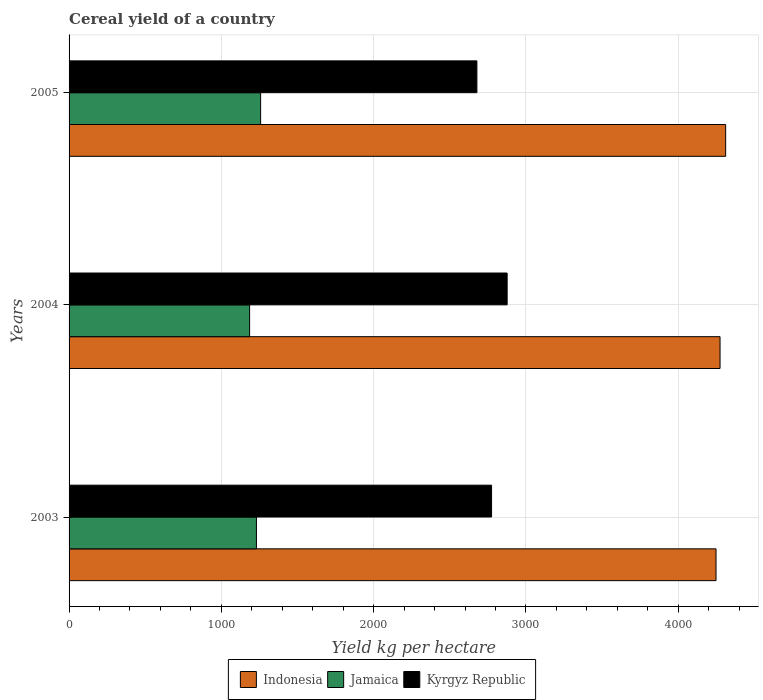How many different coloured bars are there?
Provide a succinct answer. 3. Are the number of bars per tick equal to the number of legend labels?
Provide a succinct answer. Yes. Are the number of bars on each tick of the Y-axis equal?
Give a very brief answer. Yes. How many bars are there on the 2nd tick from the top?
Your answer should be compact. 3. What is the total cereal yield in Kyrgyz Republic in 2004?
Provide a succinct answer. 2876.46. Across all years, what is the maximum total cereal yield in Jamaica?
Ensure brevity in your answer.  1257.81. Across all years, what is the minimum total cereal yield in Kyrgyz Republic?
Your answer should be very brief. 2677.87. In which year was the total cereal yield in Indonesia maximum?
Your response must be concise. 2005. In which year was the total cereal yield in Indonesia minimum?
Offer a very short reply. 2003. What is the total total cereal yield in Indonesia in the graph?
Offer a terse response. 1.28e+04. What is the difference between the total cereal yield in Kyrgyz Republic in 2004 and that in 2005?
Your response must be concise. 198.59. What is the difference between the total cereal yield in Indonesia in 2005 and the total cereal yield in Kyrgyz Republic in 2003?
Provide a short and direct response. 1537.18. What is the average total cereal yield in Indonesia per year?
Give a very brief answer. 4277.97. In the year 2003, what is the difference between the total cereal yield in Jamaica and total cereal yield in Indonesia?
Give a very brief answer. -3017.82. In how many years, is the total cereal yield in Kyrgyz Republic greater than 3800 kg per hectare?
Keep it short and to the point. 0. What is the ratio of the total cereal yield in Kyrgyz Republic in 2003 to that in 2005?
Make the answer very short. 1.04. Is the total cereal yield in Indonesia in 2003 less than that in 2005?
Your answer should be very brief. Yes. What is the difference between the highest and the second highest total cereal yield in Kyrgyz Republic?
Ensure brevity in your answer.  102.31. What is the difference between the highest and the lowest total cereal yield in Jamaica?
Make the answer very short. 72.38. In how many years, is the total cereal yield in Jamaica greater than the average total cereal yield in Jamaica taken over all years?
Your response must be concise. 2. Is the sum of the total cereal yield in Kyrgyz Republic in 2004 and 2005 greater than the maximum total cereal yield in Jamaica across all years?
Your response must be concise. Yes. What does the 3rd bar from the top in 2004 represents?
Offer a very short reply. Indonesia. What does the 1st bar from the bottom in 2004 represents?
Offer a terse response. Indonesia. How many bars are there?
Give a very brief answer. 9. Does the graph contain any zero values?
Offer a very short reply. No. Where does the legend appear in the graph?
Your response must be concise. Bottom center. How many legend labels are there?
Keep it short and to the point. 3. What is the title of the graph?
Your answer should be compact. Cereal yield of a country. Does "Europe(developing only)" appear as one of the legend labels in the graph?
Your response must be concise. No. What is the label or title of the X-axis?
Provide a succinct answer. Yield kg per hectare. What is the Yield kg per hectare of Indonesia in 2003?
Your response must be concise. 4248.09. What is the Yield kg per hectare of Jamaica in 2003?
Provide a short and direct response. 1230.26. What is the Yield kg per hectare in Kyrgyz Republic in 2003?
Provide a short and direct response. 2774.15. What is the Yield kg per hectare in Indonesia in 2004?
Your answer should be very brief. 4274.49. What is the Yield kg per hectare of Jamaica in 2004?
Make the answer very short. 1185.43. What is the Yield kg per hectare in Kyrgyz Republic in 2004?
Your answer should be very brief. 2876.46. What is the Yield kg per hectare in Indonesia in 2005?
Offer a terse response. 4311.34. What is the Yield kg per hectare in Jamaica in 2005?
Make the answer very short. 1257.81. What is the Yield kg per hectare of Kyrgyz Republic in 2005?
Your answer should be compact. 2677.87. Across all years, what is the maximum Yield kg per hectare in Indonesia?
Make the answer very short. 4311.34. Across all years, what is the maximum Yield kg per hectare in Jamaica?
Your answer should be compact. 1257.81. Across all years, what is the maximum Yield kg per hectare in Kyrgyz Republic?
Provide a short and direct response. 2876.46. Across all years, what is the minimum Yield kg per hectare of Indonesia?
Offer a very short reply. 4248.09. Across all years, what is the minimum Yield kg per hectare in Jamaica?
Your answer should be compact. 1185.43. Across all years, what is the minimum Yield kg per hectare of Kyrgyz Republic?
Ensure brevity in your answer.  2677.87. What is the total Yield kg per hectare of Indonesia in the graph?
Provide a short and direct response. 1.28e+04. What is the total Yield kg per hectare in Jamaica in the graph?
Your answer should be very brief. 3673.51. What is the total Yield kg per hectare in Kyrgyz Republic in the graph?
Your response must be concise. 8328.49. What is the difference between the Yield kg per hectare of Indonesia in 2003 and that in 2004?
Your answer should be compact. -26.4. What is the difference between the Yield kg per hectare in Jamaica in 2003 and that in 2004?
Provide a short and direct response. 44.83. What is the difference between the Yield kg per hectare of Kyrgyz Republic in 2003 and that in 2004?
Offer a terse response. -102.31. What is the difference between the Yield kg per hectare of Indonesia in 2003 and that in 2005?
Your answer should be very brief. -63.25. What is the difference between the Yield kg per hectare in Jamaica in 2003 and that in 2005?
Make the answer very short. -27.55. What is the difference between the Yield kg per hectare of Kyrgyz Republic in 2003 and that in 2005?
Your answer should be very brief. 96.28. What is the difference between the Yield kg per hectare in Indonesia in 2004 and that in 2005?
Your response must be concise. -36.85. What is the difference between the Yield kg per hectare in Jamaica in 2004 and that in 2005?
Your answer should be very brief. -72.38. What is the difference between the Yield kg per hectare in Kyrgyz Republic in 2004 and that in 2005?
Your answer should be compact. 198.59. What is the difference between the Yield kg per hectare of Indonesia in 2003 and the Yield kg per hectare of Jamaica in 2004?
Your answer should be compact. 3062.66. What is the difference between the Yield kg per hectare of Indonesia in 2003 and the Yield kg per hectare of Kyrgyz Republic in 2004?
Make the answer very short. 1371.62. What is the difference between the Yield kg per hectare in Jamaica in 2003 and the Yield kg per hectare in Kyrgyz Republic in 2004?
Give a very brief answer. -1646.2. What is the difference between the Yield kg per hectare of Indonesia in 2003 and the Yield kg per hectare of Jamaica in 2005?
Give a very brief answer. 2990.27. What is the difference between the Yield kg per hectare of Indonesia in 2003 and the Yield kg per hectare of Kyrgyz Republic in 2005?
Your response must be concise. 1570.22. What is the difference between the Yield kg per hectare in Jamaica in 2003 and the Yield kg per hectare in Kyrgyz Republic in 2005?
Offer a very short reply. -1447.61. What is the difference between the Yield kg per hectare in Indonesia in 2004 and the Yield kg per hectare in Jamaica in 2005?
Make the answer very short. 3016.68. What is the difference between the Yield kg per hectare in Indonesia in 2004 and the Yield kg per hectare in Kyrgyz Republic in 2005?
Provide a succinct answer. 1596.62. What is the difference between the Yield kg per hectare of Jamaica in 2004 and the Yield kg per hectare of Kyrgyz Republic in 2005?
Provide a short and direct response. -1492.44. What is the average Yield kg per hectare in Indonesia per year?
Your answer should be very brief. 4277.97. What is the average Yield kg per hectare in Jamaica per year?
Your answer should be compact. 1224.5. What is the average Yield kg per hectare in Kyrgyz Republic per year?
Offer a terse response. 2776.16. In the year 2003, what is the difference between the Yield kg per hectare in Indonesia and Yield kg per hectare in Jamaica?
Your response must be concise. 3017.82. In the year 2003, what is the difference between the Yield kg per hectare in Indonesia and Yield kg per hectare in Kyrgyz Republic?
Ensure brevity in your answer.  1473.93. In the year 2003, what is the difference between the Yield kg per hectare in Jamaica and Yield kg per hectare in Kyrgyz Republic?
Ensure brevity in your answer.  -1543.89. In the year 2004, what is the difference between the Yield kg per hectare in Indonesia and Yield kg per hectare in Jamaica?
Keep it short and to the point. 3089.06. In the year 2004, what is the difference between the Yield kg per hectare of Indonesia and Yield kg per hectare of Kyrgyz Republic?
Give a very brief answer. 1398.03. In the year 2004, what is the difference between the Yield kg per hectare of Jamaica and Yield kg per hectare of Kyrgyz Republic?
Your response must be concise. -1691.03. In the year 2005, what is the difference between the Yield kg per hectare of Indonesia and Yield kg per hectare of Jamaica?
Offer a very short reply. 3053.52. In the year 2005, what is the difference between the Yield kg per hectare of Indonesia and Yield kg per hectare of Kyrgyz Republic?
Give a very brief answer. 1633.47. In the year 2005, what is the difference between the Yield kg per hectare in Jamaica and Yield kg per hectare in Kyrgyz Republic?
Your response must be concise. -1420.06. What is the ratio of the Yield kg per hectare in Indonesia in 2003 to that in 2004?
Ensure brevity in your answer.  0.99. What is the ratio of the Yield kg per hectare of Jamaica in 2003 to that in 2004?
Make the answer very short. 1.04. What is the ratio of the Yield kg per hectare of Kyrgyz Republic in 2003 to that in 2004?
Provide a succinct answer. 0.96. What is the ratio of the Yield kg per hectare of Indonesia in 2003 to that in 2005?
Give a very brief answer. 0.99. What is the ratio of the Yield kg per hectare in Jamaica in 2003 to that in 2005?
Keep it short and to the point. 0.98. What is the ratio of the Yield kg per hectare in Kyrgyz Republic in 2003 to that in 2005?
Provide a short and direct response. 1.04. What is the ratio of the Yield kg per hectare in Jamaica in 2004 to that in 2005?
Offer a terse response. 0.94. What is the ratio of the Yield kg per hectare of Kyrgyz Republic in 2004 to that in 2005?
Your answer should be very brief. 1.07. What is the difference between the highest and the second highest Yield kg per hectare in Indonesia?
Your response must be concise. 36.85. What is the difference between the highest and the second highest Yield kg per hectare of Jamaica?
Your answer should be very brief. 27.55. What is the difference between the highest and the second highest Yield kg per hectare in Kyrgyz Republic?
Your answer should be very brief. 102.31. What is the difference between the highest and the lowest Yield kg per hectare in Indonesia?
Make the answer very short. 63.25. What is the difference between the highest and the lowest Yield kg per hectare of Jamaica?
Ensure brevity in your answer.  72.38. What is the difference between the highest and the lowest Yield kg per hectare in Kyrgyz Republic?
Provide a short and direct response. 198.59. 